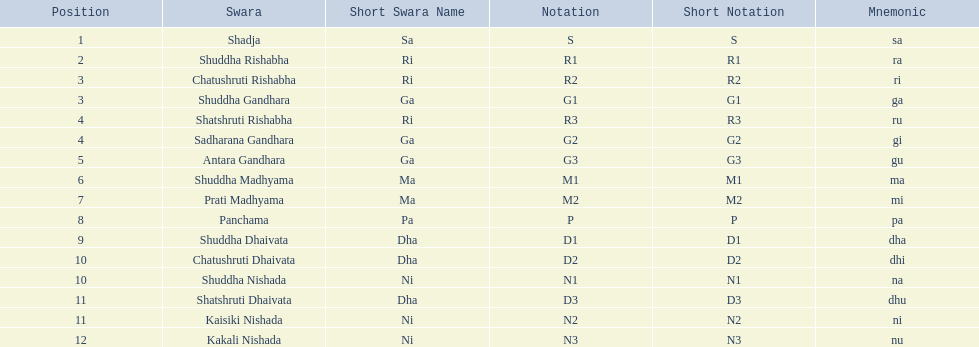What swara is above shatshruti dhaivata? Shuddha Nishada. 